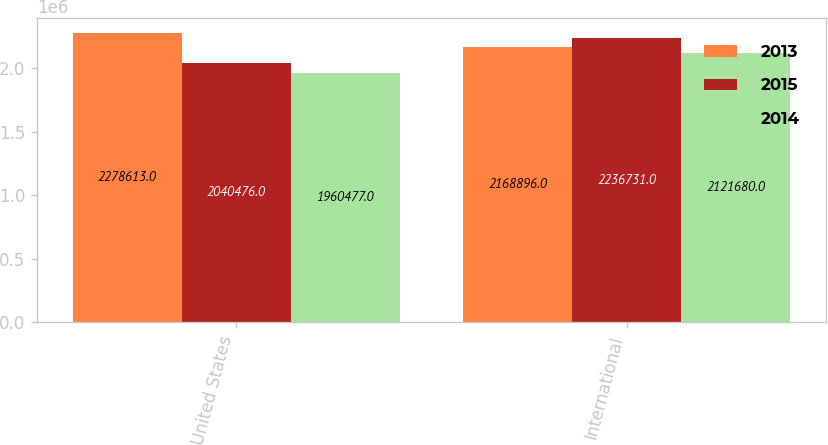<chart> <loc_0><loc_0><loc_500><loc_500><stacked_bar_chart><ecel><fcel>United States<fcel>International<nl><fcel>2013<fcel>2.27861e+06<fcel>2.1689e+06<nl><fcel>2015<fcel>2.04048e+06<fcel>2.23673e+06<nl><fcel>2014<fcel>1.96048e+06<fcel>2.12168e+06<nl></chart> 